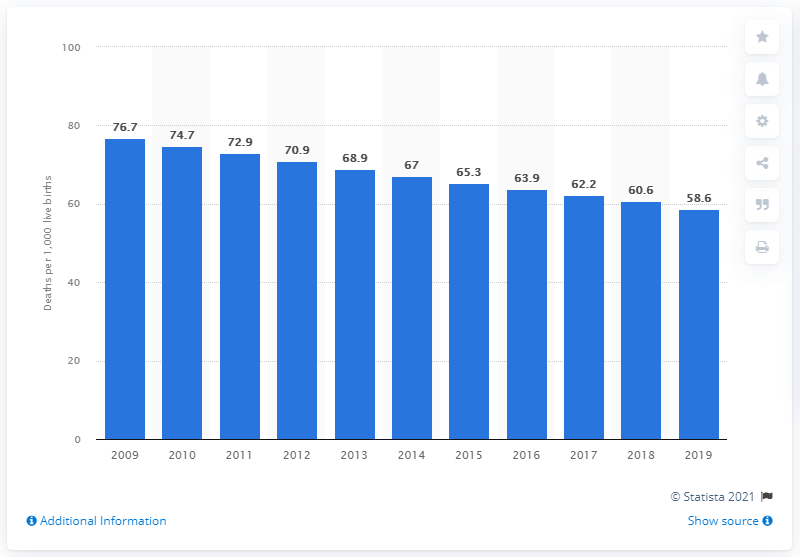Point out several critical features in this image. In 2019, the infant mortality rate in Cote d'Ivoire was 58.6 deaths per 1,000 live births. 